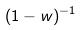<formula> <loc_0><loc_0><loc_500><loc_500>( 1 - w ) ^ { - 1 }</formula> 